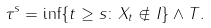Convert formula to latex. <formula><loc_0><loc_0><loc_500><loc_500>\tau ^ { s } & = \inf \{ t \geq s \colon X _ { t } \notin I \} \wedge T .</formula> 